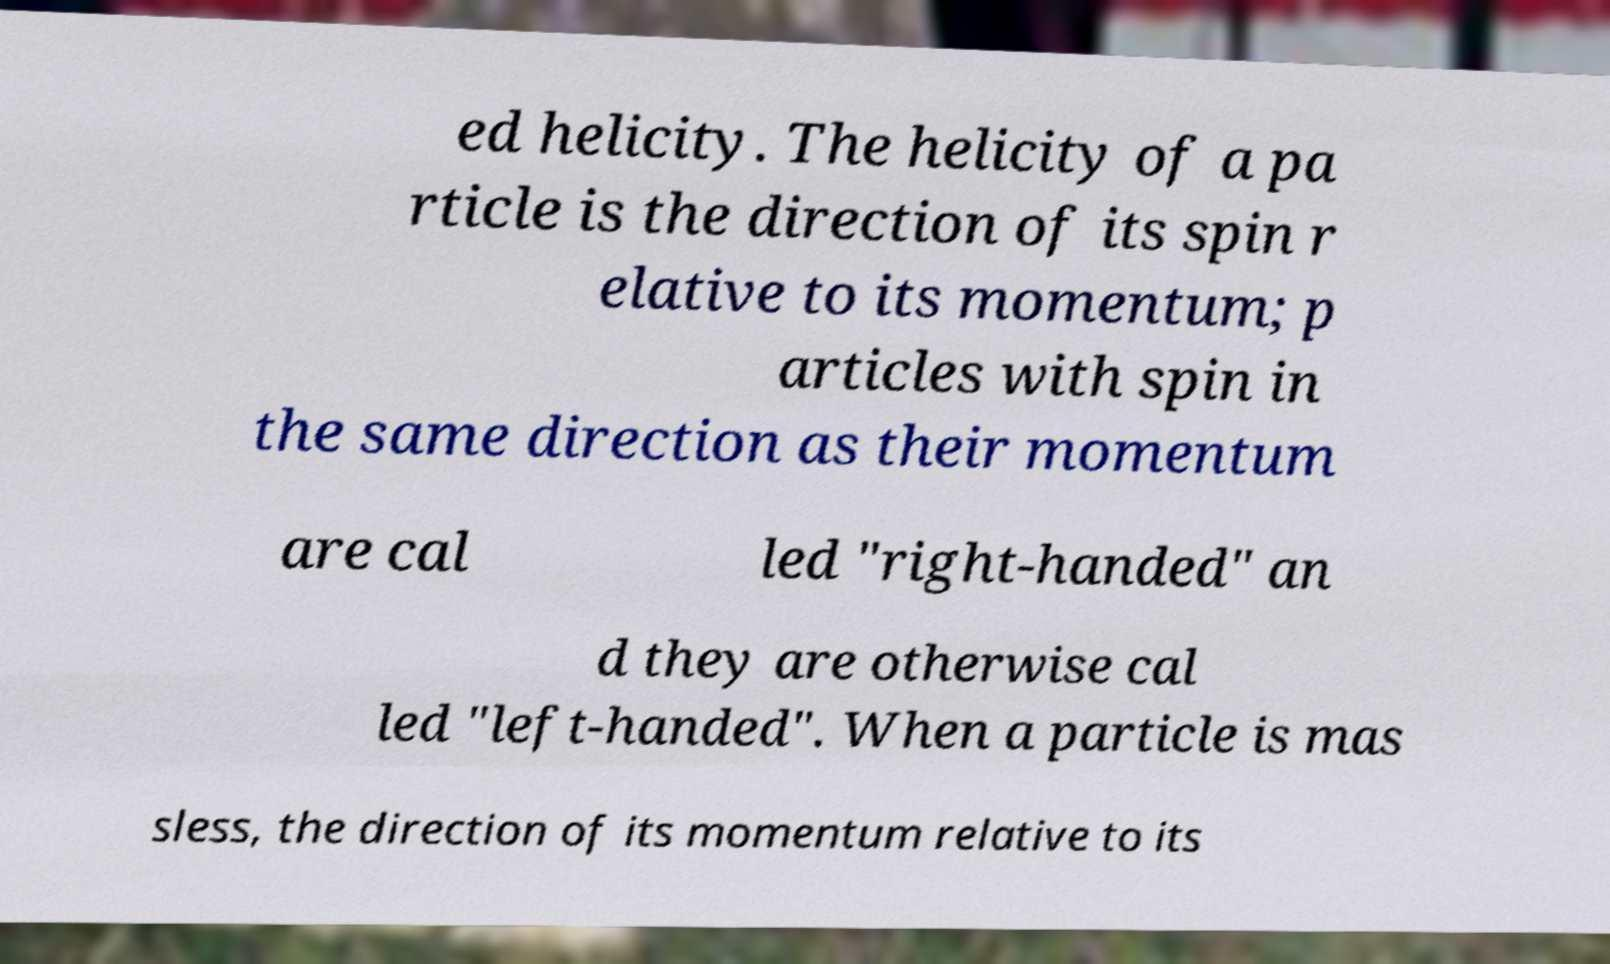Could you assist in decoding the text presented in this image and type it out clearly? ed helicity. The helicity of a pa rticle is the direction of its spin r elative to its momentum; p articles with spin in the same direction as their momentum are cal led "right-handed" an d they are otherwise cal led "left-handed". When a particle is mas sless, the direction of its momentum relative to its 